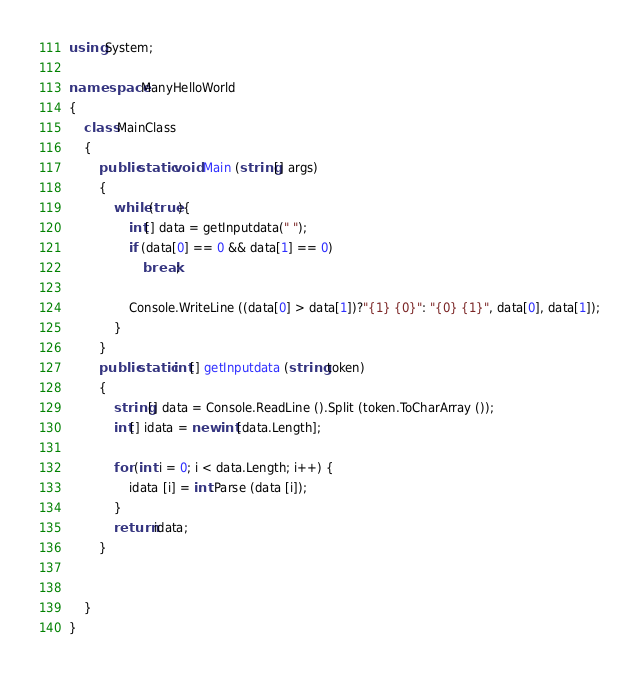Convert code to text. <code><loc_0><loc_0><loc_500><loc_500><_C#_>using System;

namespace ManyHelloWorld
{
	class MainClass
	{
		public static void Main (string[] args)
		{
			while (true){
				int[] data = getInputdata(" ");
				if (data[0] == 0 && data[1] == 0)
					break;

				Console.WriteLine ((data[0] > data[1])?"{1} {0}": "{0} {1}", data[0], data[1]);
			}
		}
		public static int[] getInputdata (string token)
		{
			string[] data = Console.ReadLine ().Split (token.ToCharArray ());
			int[] idata = new int[data.Length];

			for (int i = 0; i < data.Length; i++) {
				idata [i] = int.Parse (data [i]);
			}
			return idata;
		}


	}
}</code> 